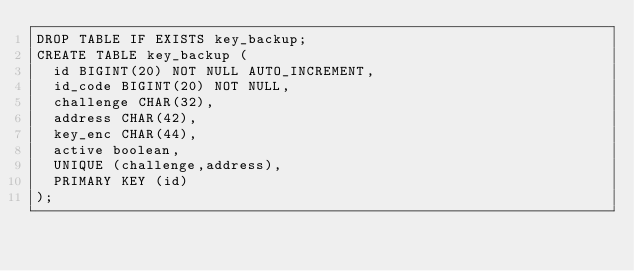Convert code to text. <code><loc_0><loc_0><loc_500><loc_500><_SQL_>DROP TABLE IF EXISTS key_backup;
CREATE TABLE key_backup (
  id BIGINT(20) NOT NULL AUTO_INCREMENT,
  id_code BIGINT(20) NOT NULL,
  challenge CHAR(32),
  address CHAR(42),
  key_enc CHAR(44),
  active boolean,
  UNIQUE (challenge,address),
  PRIMARY KEY (id)
);
</code> 